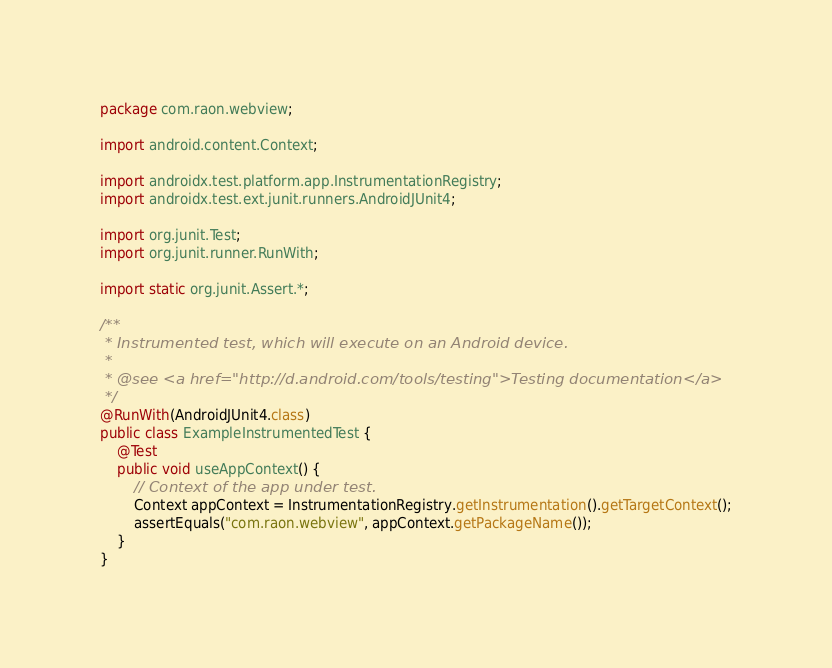<code> <loc_0><loc_0><loc_500><loc_500><_Java_>package com.raon.webview;

import android.content.Context;

import androidx.test.platform.app.InstrumentationRegistry;
import androidx.test.ext.junit.runners.AndroidJUnit4;

import org.junit.Test;
import org.junit.runner.RunWith;

import static org.junit.Assert.*;

/**
 * Instrumented test, which will execute on an Android device.
 *
 * @see <a href="http://d.android.com/tools/testing">Testing documentation</a>
 */
@RunWith(AndroidJUnit4.class)
public class ExampleInstrumentedTest {
    @Test
    public void useAppContext() {
        // Context of the app under test.
        Context appContext = InstrumentationRegistry.getInstrumentation().getTargetContext();
        assertEquals("com.raon.webview", appContext.getPackageName());
    }
}</code> 